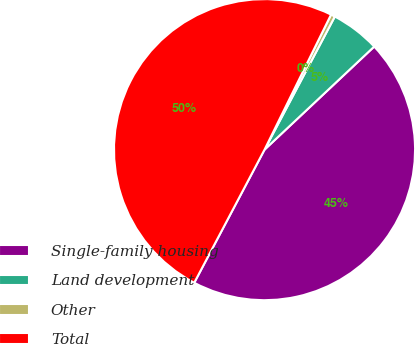<chart> <loc_0><loc_0><loc_500><loc_500><pie_chart><fcel>Single-family housing<fcel>Land development<fcel>Other<fcel>Total<nl><fcel>44.74%<fcel>5.26%<fcel>0.45%<fcel>49.55%<nl></chart> 